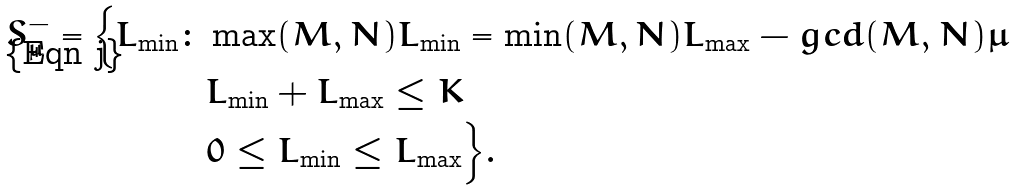<formula> <loc_0><loc_0><loc_500><loc_500>S ^ { - } _ { \mu } = \Big { \{ } L _ { \min } \colon & \max ( M , N ) L _ { \min } = \min ( M , N ) L _ { \max } - g c d ( M , N ) \mu \\ & L _ { \min } + L _ { \max } \leq K \\ & 0 \leq L _ { \min } \leq L _ { \max } \Big { \} } .</formula> 